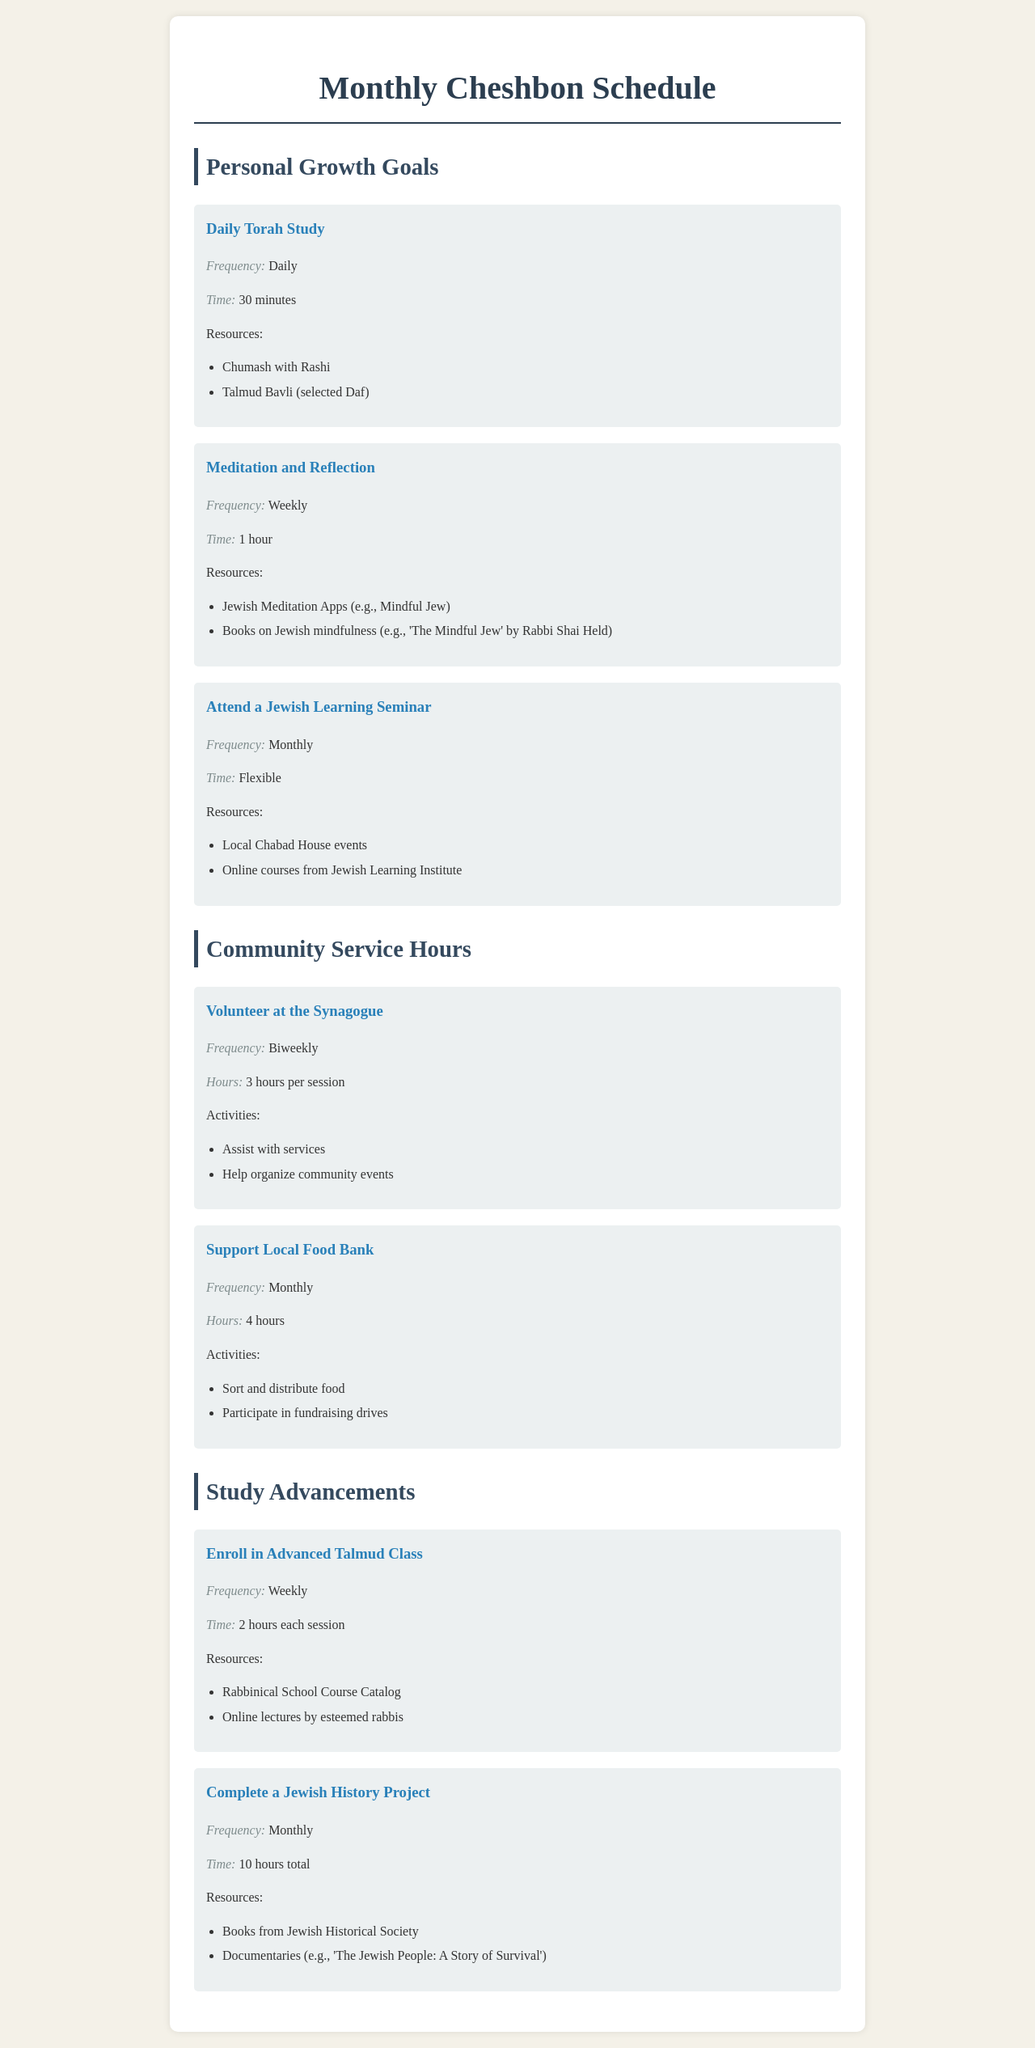What is the frequency of Daily Torah Study? The document states that Daily Torah Study is to be done every day.
Answer: Daily How long should you meditate and reflect each week? According to the schedule, meditation and reflection should take 1 hour weekly.
Answer: 1 hour How many hours do you volunteer at the synagogue per session? The schedule indicates that you volunteer 3 hours during each session at the synagogue.
Answer: 3 hours What is the time allocated for each session of the Advanced Talmud Class? The document specifies that each session of the Advanced Talmud Class is 2 hours long.
Answer: 2 hours How often do you need to complete a Jewish History Project? The schedule outlines that a Jewish History Project needs to be completed monthly.
Answer: Monthly What types of resources are suggested for Meditation and Reflection? The document lists Jewish meditation apps and books on Jewish mindfulness as resources for meditation and reflection.
Answer: Jewish Meditation Apps, Books on Jewish mindfulness How many total hours are required to complete a Jewish History Project? The schedule states that a Jewish History Project requires a total of 10 hours.
Answer: 10 hours What activities are involved in volunteering at the synagogue? The document notes assisting with services and helping organize community events as activities for synagogue volunteering.
Answer: Assist with services, Help organize community events What is the frequency of supporting the local food bank? The document indicates that supporting the local food bank occurs monthly.
Answer: Monthly 